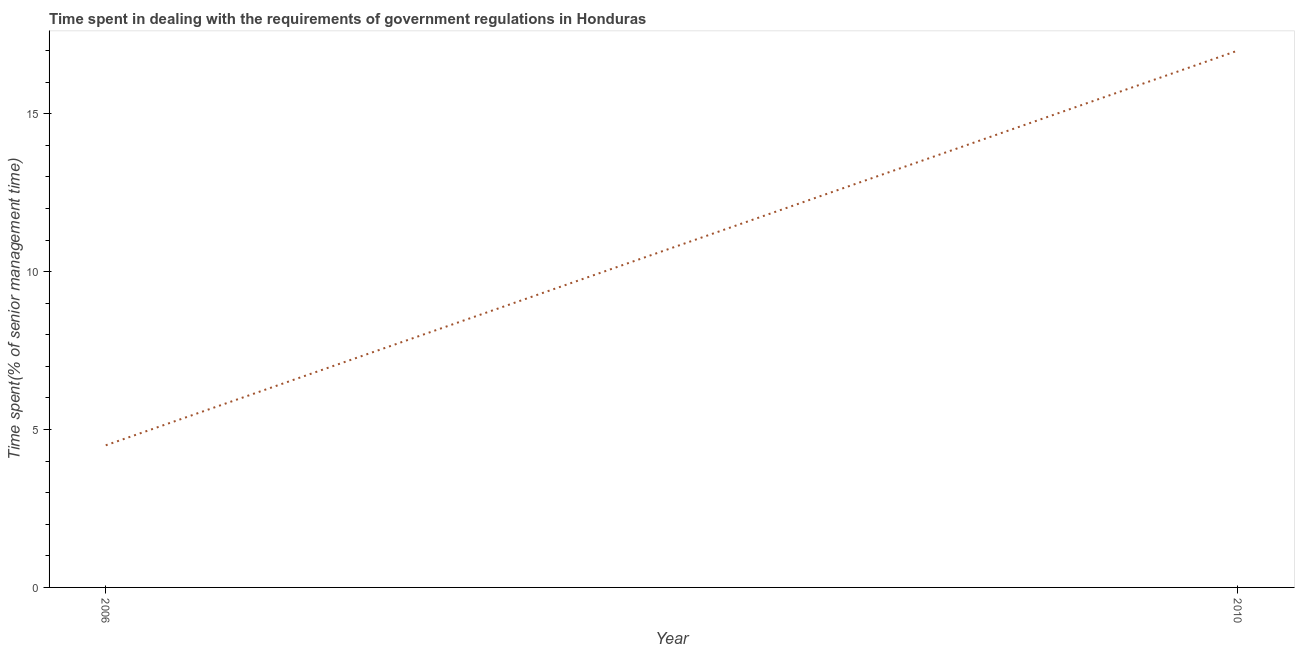What is the time spent in dealing with government regulations in 2006?
Ensure brevity in your answer.  4.5. Across all years, what is the maximum time spent in dealing with government regulations?
Your answer should be compact. 17. What is the sum of the time spent in dealing with government regulations?
Offer a terse response. 21.5. What is the difference between the time spent in dealing with government regulations in 2006 and 2010?
Your response must be concise. -12.5. What is the average time spent in dealing with government regulations per year?
Your answer should be compact. 10.75. What is the median time spent in dealing with government regulations?
Provide a short and direct response. 10.75. Do a majority of the years between 2010 and 2006 (inclusive) have time spent in dealing with government regulations greater than 16 %?
Keep it short and to the point. No. What is the ratio of the time spent in dealing with government regulations in 2006 to that in 2010?
Your response must be concise. 0.26. Is the time spent in dealing with government regulations in 2006 less than that in 2010?
Ensure brevity in your answer.  Yes. In how many years, is the time spent in dealing with government regulations greater than the average time spent in dealing with government regulations taken over all years?
Provide a short and direct response. 1. How many years are there in the graph?
Give a very brief answer. 2. What is the difference between two consecutive major ticks on the Y-axis?
Your answer should be compact. 5. Are the values on the major ticks of Y-axis written in scientific E-notation?
Keep it short and to the point. No. Does the graph contain any zero values?
Keep it short and to the point. No. What is the title of the graph?
Offer a very short reply. Time spent in dealing with the requirements of government regulations in Honduras. What is the label or title of the X-axis?
Your answer should be very brief. Year. What is the label or title of the Y-axis?
Ensure brevity in your answer.  Time spent(% of senior management time). What is the Time spent(% of senior management time) in 2010?
Your answer should be very brief. 17. What is the difference between the Time spent(% of senior management time) in 2006 and 2010?
Offer a very short reply. -12.5. What is the ratio of the Time spent(% of senior management time) in 2006 to that in 2010?
Offer a very short reply. 0.27. 